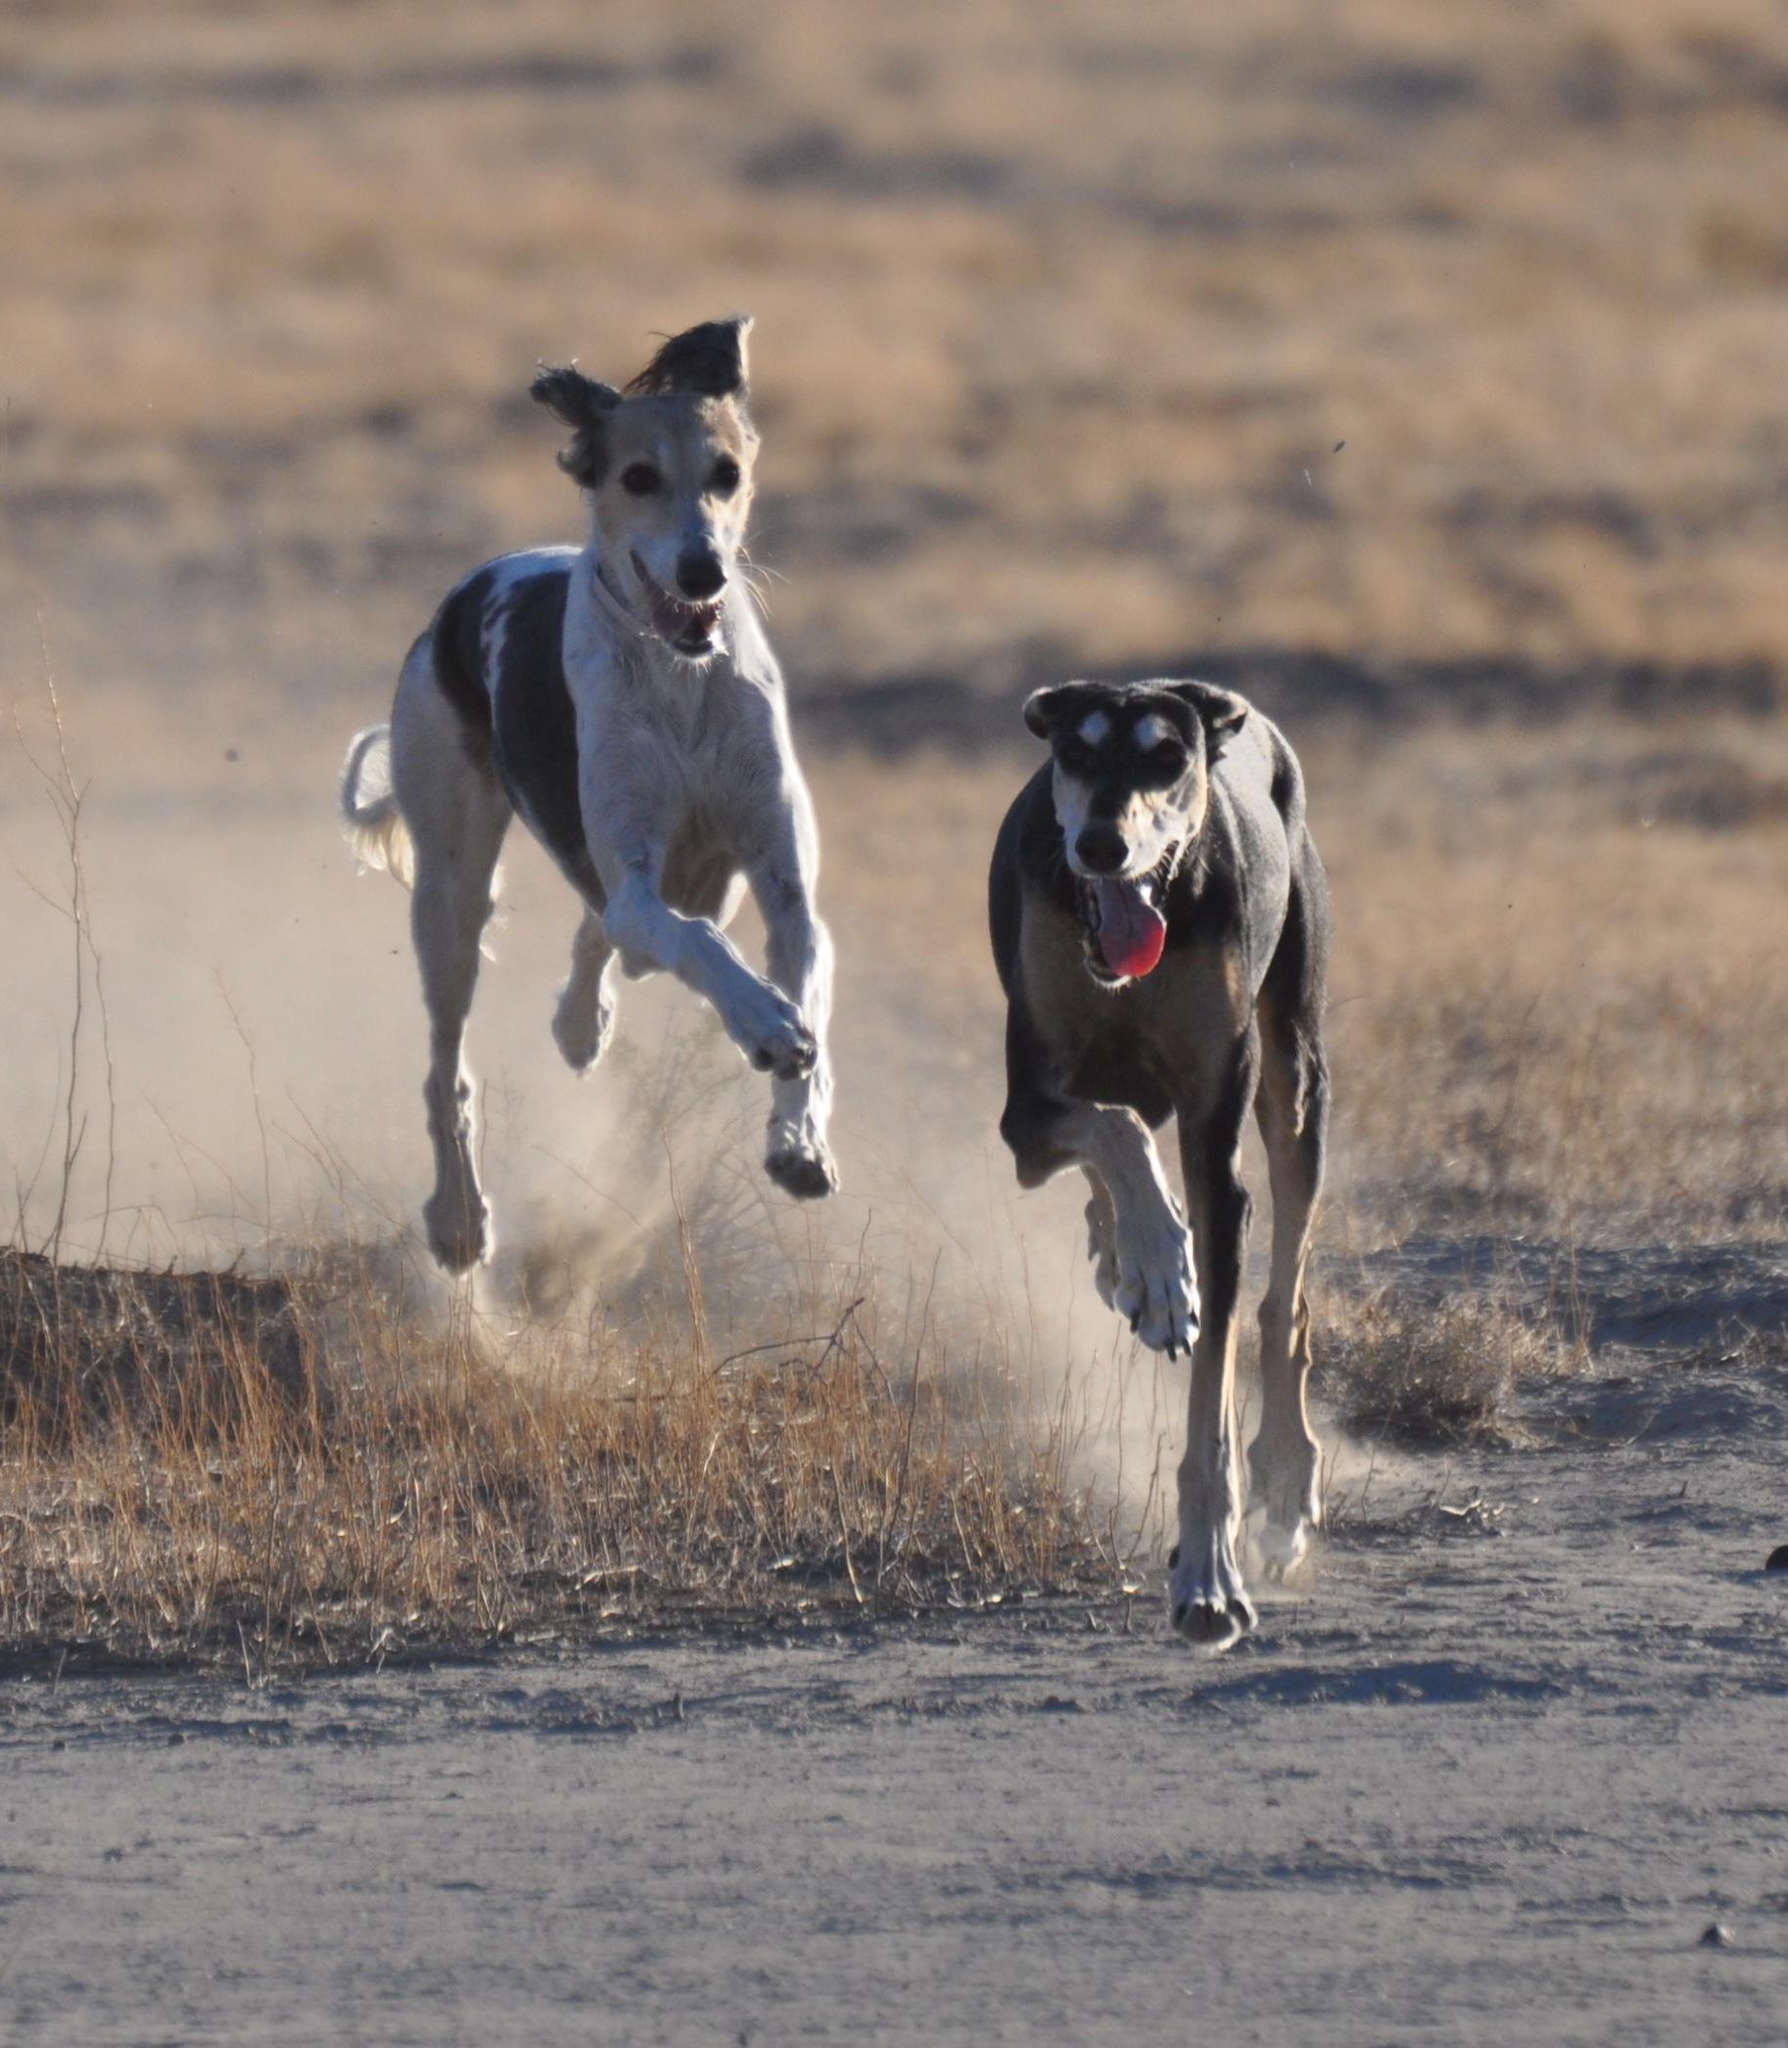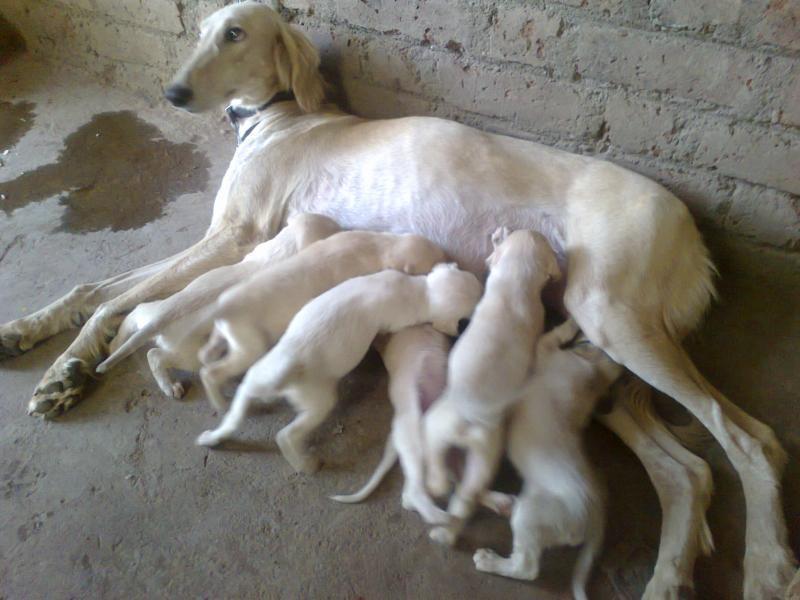The first image is the image on the left, the second image is the image on the right. Analyze the images presented: Is the assertion "An image shows one hound running in front of another and kicking up clouds of dust." valid? Answer yes or no. Yes. The first image is the image on the left, the second image is the image on the right. Analyze the images presented: Is the assertion "One animal is on a leash." valid? Answer yes or no. No. 